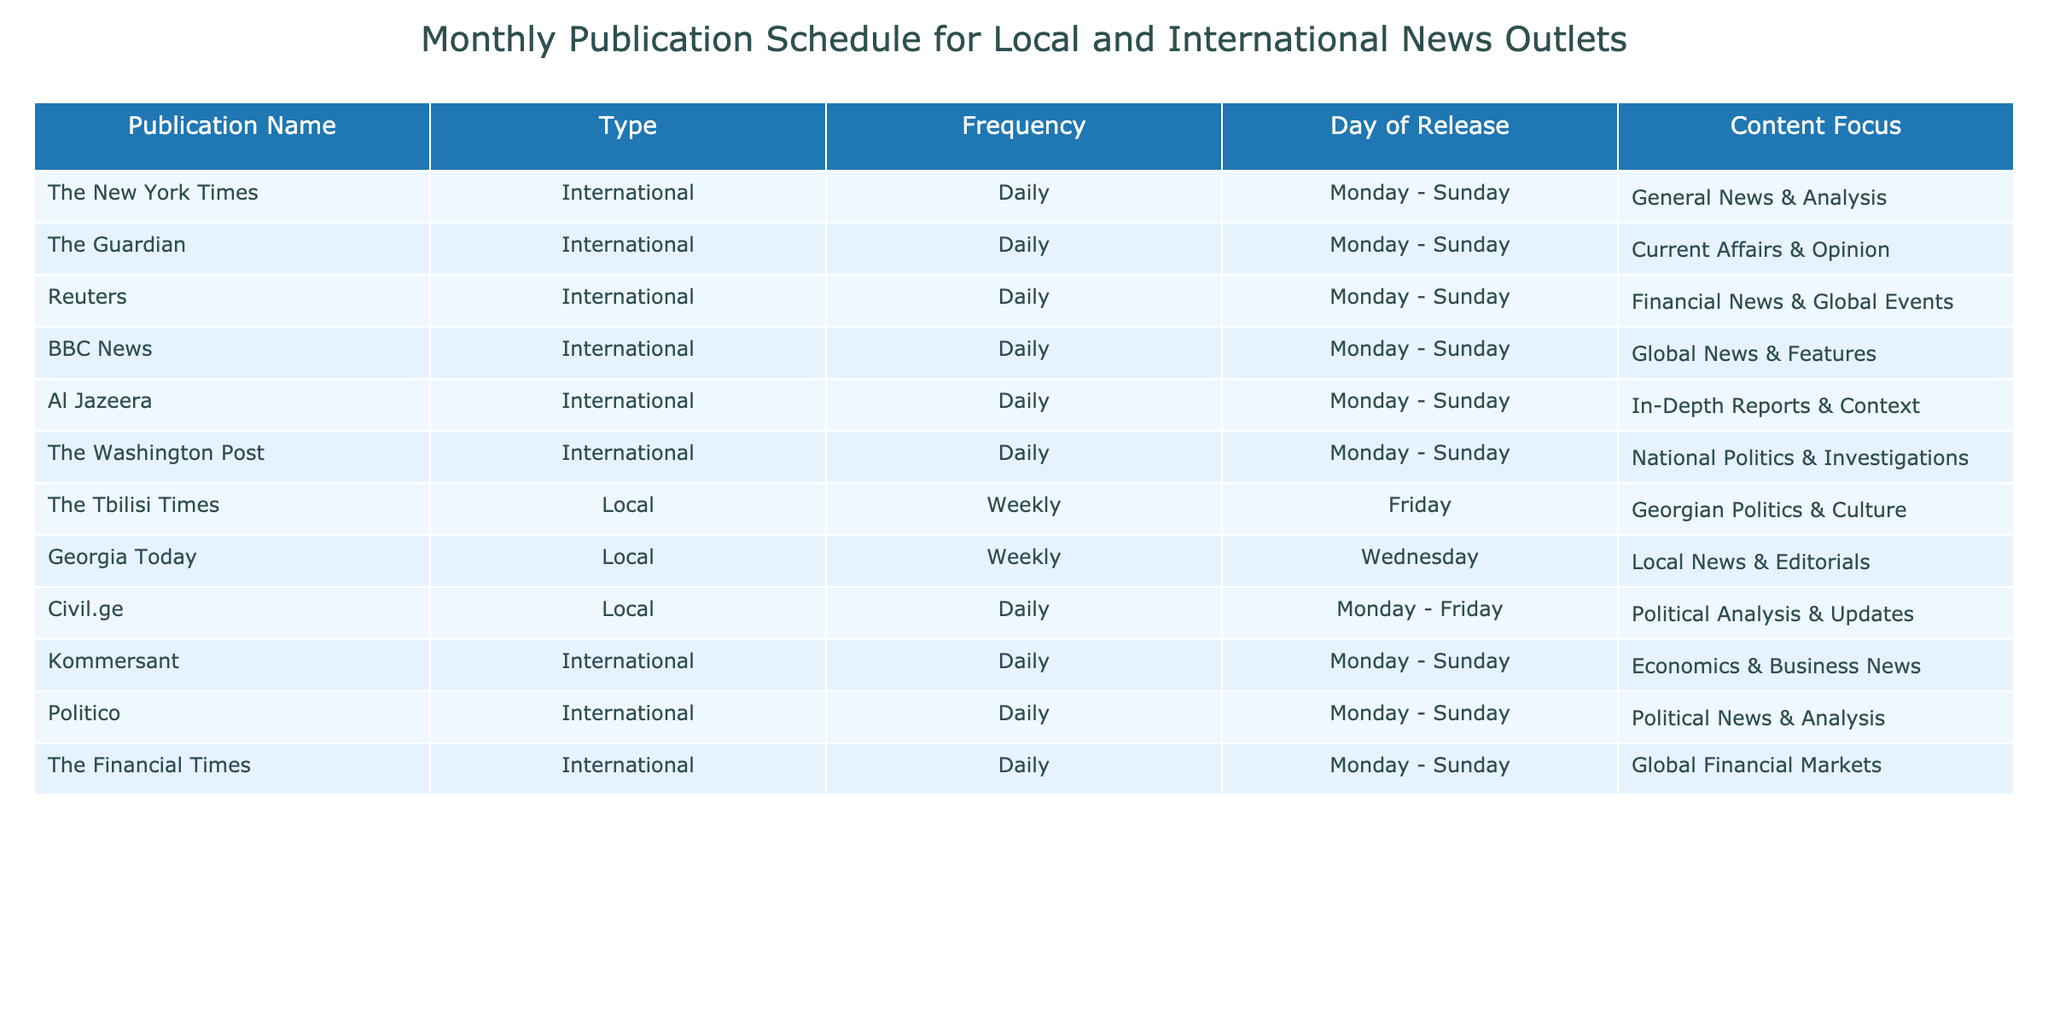What is the frequency of The Tbilisi Times? The Tbilisi Times is listed as a local publication in the table, and its frequency is noted as "Weekly."
Answer: Weekly How many international publications are released daily? By examining the table, we can see that five international publications (The New York Times, The Guardian, Reuters, BBC News, Al Jazeera, The Washington Post, Kommersant, Politico, and The Financial Times) are listed, all having a daily frequency.
Answer: 9 Which publication focuses specifically on Georgian politics and culture? The Tbilisi Times is highlighted in the table under the local section and clearly indicates its focus on "Georgian Politics & Culture."
Answer: The Tbilisi Times Are there any publications that have both a daily frequency and a political focus? Yes, Civil.ge is listed as a local publication with a daily frequency, focusing on "Political Analysis & Updates." Therefore, it is one such publication that fits this description.
Answer: Yes What is the content focus of The Financial Times? The Financial Times is classified as an international publication, and its content focus, according to the table, is "Global Financial Markets."
Answer: Global Financial Markets Which day of the week does Georgia Today release its content? In the provided data, Georgia Today is indicated as a weekly publication that releases its content on Wednesdays.
Answer: Wednesday What is the content focus of the publication with the highest frequency? Considering the information in the table, the publication with the highest frequency is Civil.ge, which has a focus on "Political Analysis & Updates."
Answer: Political Analysis & Updates Which local publication publishes on Fridays? According to the table, The Tbilisi Times is the local publication that releases its content on Fridays.
Answer: The Tbilisi Times How many total types of publications are listed in the table? The table indicates there are two types of publications: Local and International. Therefore, the total types of publications is 2.
Answer: 2 Are there any local publications that publish daily? Based on the table, all the local publications (The Tbilisi Times, Georgia Today, and Civil.ge) indicate that Civil.ge is the only one publishing daily, while others publish weekly.
Answer: No 